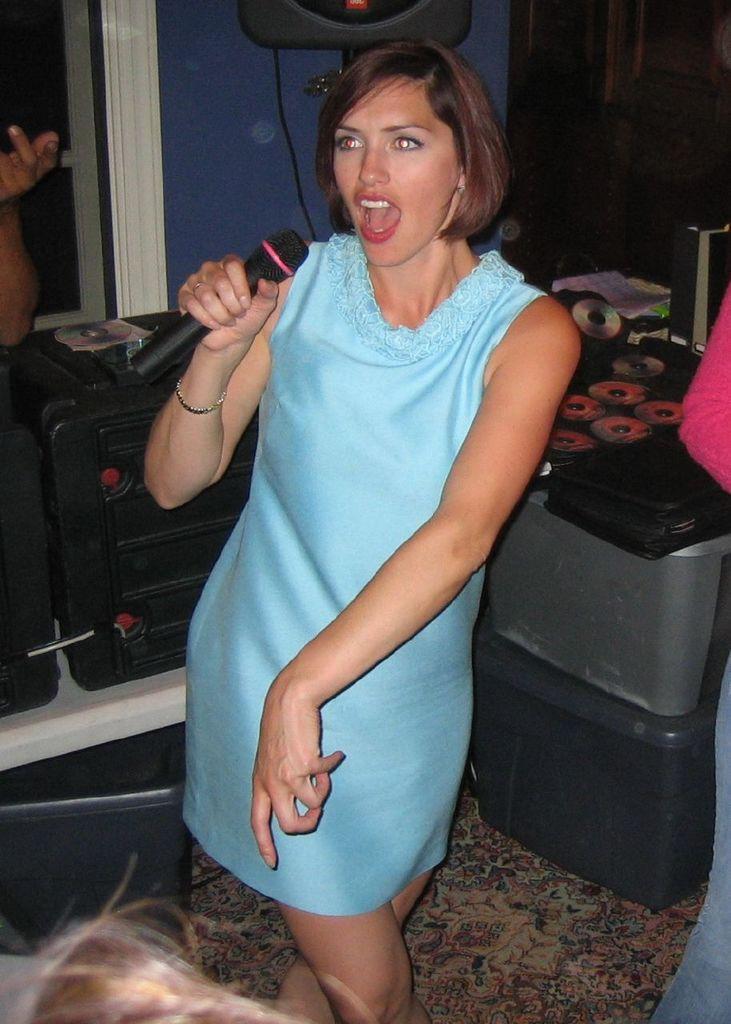In one or two sentences, can you explain what this image depicts? In this picture I can see a woman holding microphone. I can see musical instruments. 